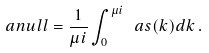<formula> <loc_0><loc_0><loc_500><loc_500>\ a n u l l = \frac { 1 } { \mu i } \int _ { 0 } ^ { \mu i } \ a s ( k ) d k \, .</formula> 